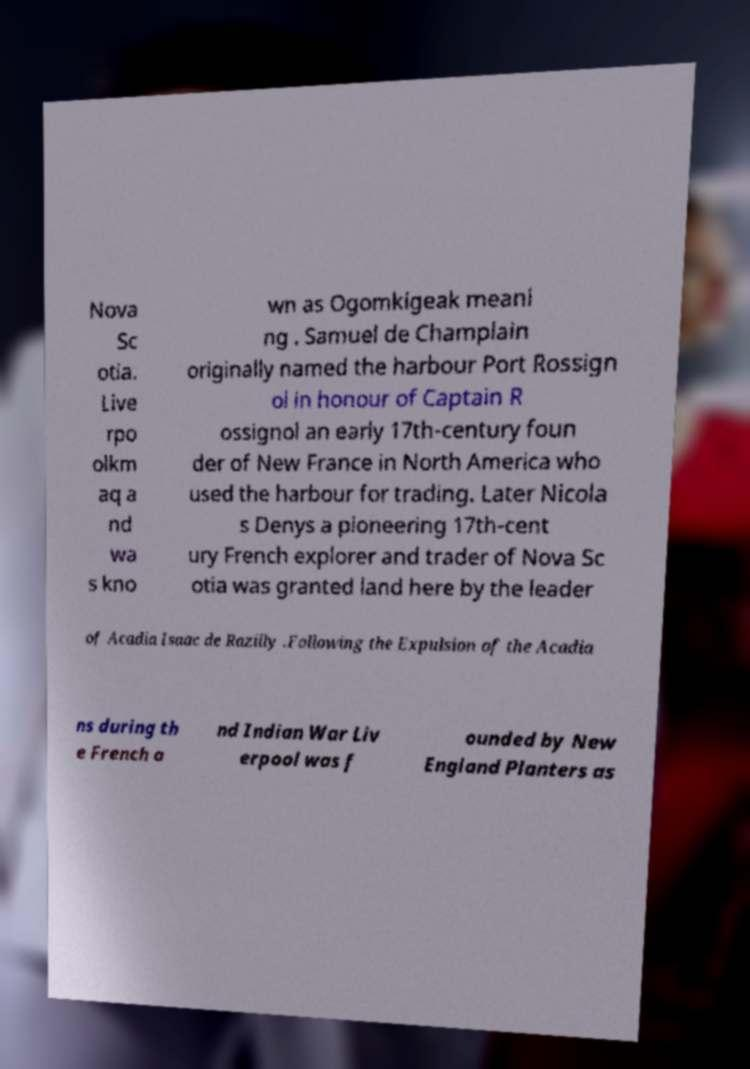Could you extract and type out the text from this image? Nova Sc otia. Live rpo olkm aq a nd wa s kno wn as Ogomkigeak meani ng . Samuel de Champlain originally named the harbour Port Rossign ol in honour of Captain R ossignol an early 17th-century foun der of New France in North America who used the harbour for trading. Later Nicola s Denys a pioneering 17th-cent ury French explorer and trader of Nova Sc otia was granted land here by the leader of Acadia Isaac de Razilly .Following the Expulsion of the Acadia ns during th e French a nd Indian War Liv erpool was f ounded by New England Planters as 